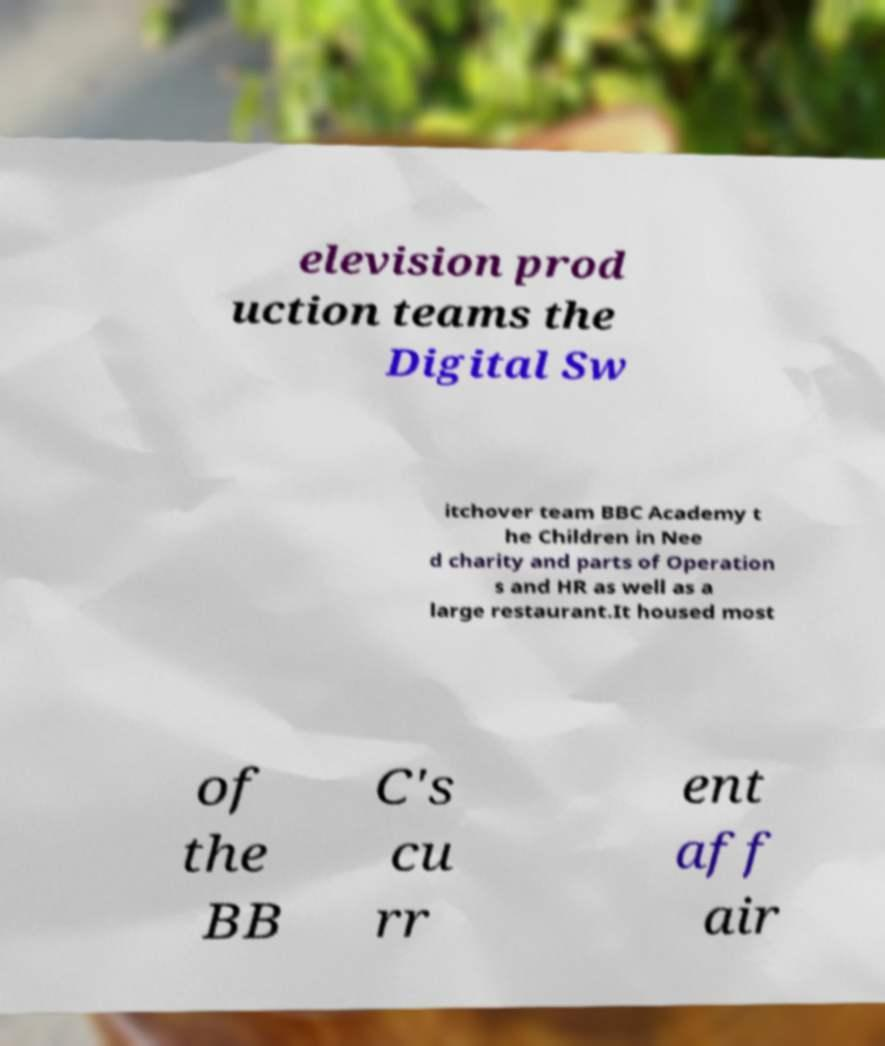What messages or text are displayed in this image? I need them in a readable, typed format. elevision prod uction teams the Digital Sw itchover team BBC Academy t he Children in Nee d charity and parts of Operation s and HR as well as a large restaurant.It housed most of the BB C's cu rr ent aff air 